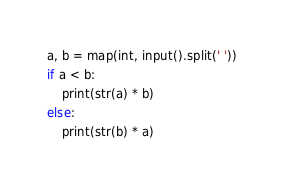<code> <loc_0><loc_0><loc_500><loc_500><_Python_>a, b = map(int, input().split(' '))
if a < b:
    print(str(a) * b)
else:
    print(str(b) * a)</code> 